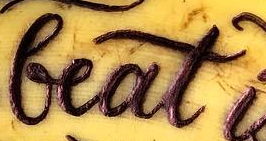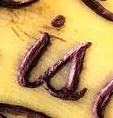Read the text content from these images in order, separated by a semicolon. beat; is 